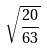<formula> <loc_0><loc_0><loc_500><loc_500>\sqrt { \frac { 2 0 } { 6 3 } }</formula> 